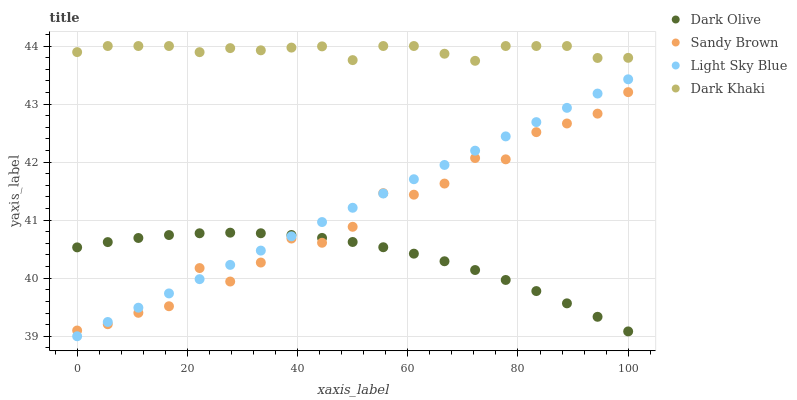Does Dark Olive have the minimum area under the curve?
Answer yes or no. Yes. Does Dark Khaki have the maximum area under the curve?
Answer yes or no. Yes. Does Sandy Brown have the minimum area under the curve?
Answer yes or no. No. Does Sandy Brown have the maximum area under the curve?
Answer yes or no. No. Is Light Sky Blue the smoothest?
Answer yes or no. Yes. Is Sandy Brown the roughest?
Answer yes or no. Yes. Is Dark Olive the smoothest?
Answer yes or no. No. Is Dark Olive the roughest?
Answer yes or no. No. Does Light Sky Blue have the lowest value?
Answer yes or no. Yes. Does Dark Olive have the lowest value?
Answer yes or no. No. Does Dark Khaki have the highest value?
Answer yes or no. Yes. Does Sandy Brown have the highest value?
Answer yes or no. No. Is Dark Olive less than Dark Khaki?
Answer yes or no. Yes. Is Dark Khaki greater than Dark Olive?
Answer yes or no. Yes. Does Light Sky Blue intersect Dark Olive?
Answer yes or no. Yes. Is Light Sky Blue less than Dark Olive?
Answer yes or no. No. Is Light Sky Blue greater than Dark Olive?
Answer yes or no. No. Does Dark Olive intersect Dark Khaki?
Answer yes or no. No. 